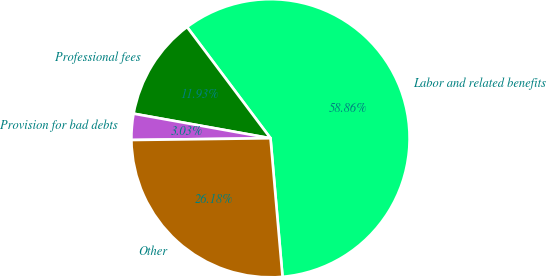Convert chart to OTSL. <chart><loc_0><loc_0><loc_500><loc_500><pie_chart><fcel>Labor and related benefits<fcel>Professional fees<fcel>Provision for bad debts<fcel>Other<nl><fcel>58.87%<fcel>11.93%<fcel>3.03%<fcel>26.18%<nl></chart> 